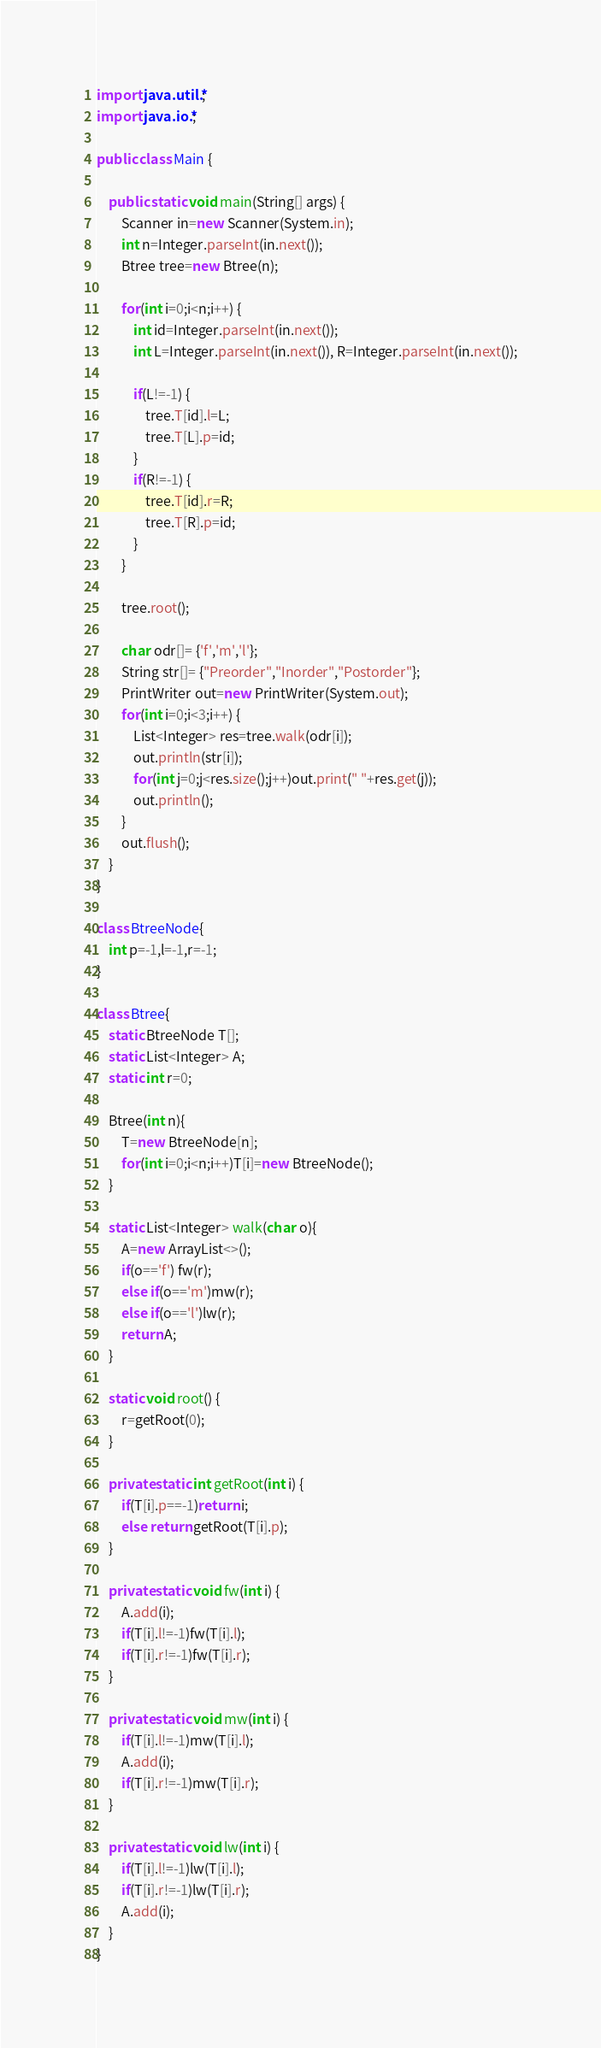<code> <loc_0><loc_0><loc_500><loc_500><_Java_>
import java.util.*;
import java.io.*;

public class Main {
	
	public static void main(String[] args) {
		Scanner in=new Scanner(System.in);
		int n=Integer.parseInt(in.next());
		Btree tree=new Btree(n);
		
		for(int i=0;i<n;i++) {
			int id=Integer.parseInt(in.next());
			int L=Integer.parseInt(in.next()), R=Integer.parseInt(in.next());
			
			if(L!=-1) {
				tree.T[id].l=L;
				tree.T[L].p=id;
			}
			if(R!=-1) {
				tree.T[id].r=R;
				tree.T[R].p=id;
			}
		}
		
		tree.root();
		
		char odr[]= {'f','m','l'};
		String str[]= {"Preorder","Inorder","Postorder"};
		PrintWriter out=new PrintWriter(System.out);
		for(int i=0;i<3;i++) {
			List<Integer> res=tree.walk(odr[i]);
			out.println(str[i]);
			for(int j=0;j<res.size();j++)out.print(" "+res.get(j));
			out.println();
		}
		out.flush();
	}
}

class BtreeNode{
	int p=-1,l=-1,r=-1;
}

class Btree{
	static BtreeNode T[];	
	static List<Integer> A;
	static int r=0;
	
	Btree(int n){
		T=new BtreeNode[n];
		for(int i=0;i<n;i++)T[i]=new BtreeNode();
	}
	
	static List<Integer> walk(char o){
		A=new ArrayList<>();
		if(o=='f') fw(r);
		else if(o=='m')mw(r);
		else if(o=='l')lw(r);
		return A;
	}
	
	static void root() {
		r=getRoot(0);
	}
	
	private static int getRoot(int i) {
		if(T[i].p==-1)return i;
		else return getRoot(T[i].p);
	}
	
	private static void fw(int i) {
		A.add(i);
		if(T[i].l!=-1)fw(T[i].l);
		if(T[i].r!=-1)fw(T[i].r);
	}
	
	private static void mw(int i) {
		if(T[i].l!=-1)mw(T[i].l);
		A.add(i);
		if(T[i].r!=-1)mw(T[i].r);
	}
	
	private static void lw(int i) {
		if(T[i].l!=-1)lw(T[i].l);
		if(T[i].r!=-1)lw(T[i].r);
		A.add(i);
	}
}
</code> 